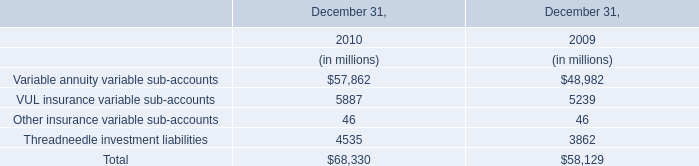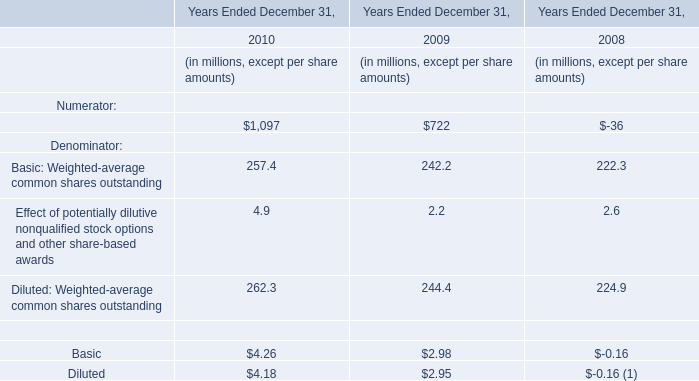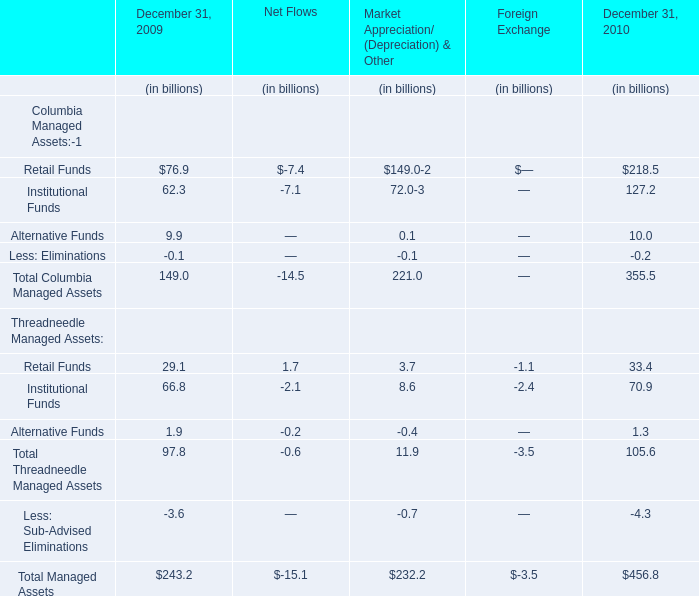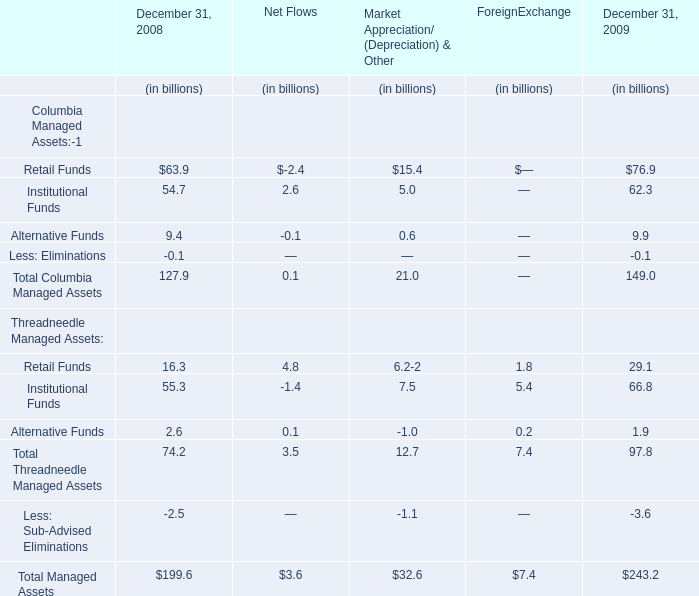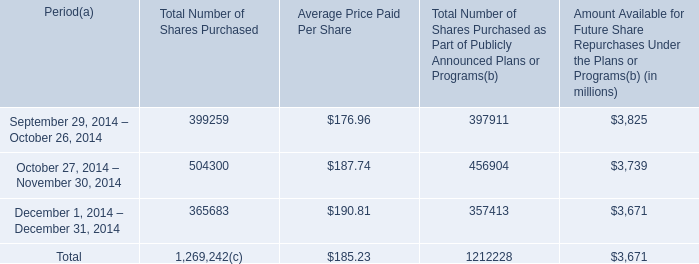what is the growth rate in the average price of the purchased shares from october to november 2014? 
Computations: ((187.74 - 176.96) / 176.96)
Answer: 0.06092. 